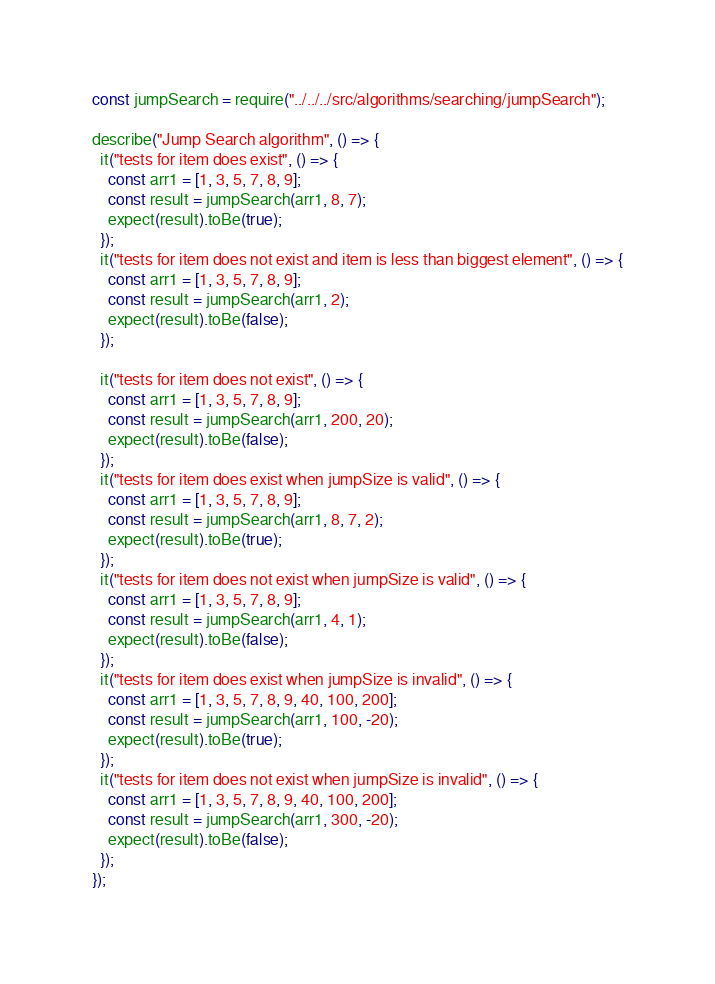<code> <loc_0><loc_0><loc_500><loc_500><_JavaScript_>const jumpSearch = require("../../../src/algorithms/searching/jumpSearch");

describe("Jump Search algorithm", () => {
  it("tests for item does exist", () => {
    const arr1 = [1, 3, 5, 7, 8, 9];
    const result = jumpSearch(arr1, 8, 7);
    expect(result).toBe(true);
  });
  it("tests for item does not exist and item is less than biggest element", () => {
    const arr1 = [1, 3, 5, 7, 8, 9];
    const result = jumpSearch(arr1, 2);
    expect(result).toBe(false);
  });

  it("tests for item does not exist", () => {
    const arr1 = [1, 3, 5, 7, 8, 9];
    const result = jumpSearch(arr1, 200, 20);
    expect(result).toBe(false);
  });
  it("tests for item does exist when jumpSize is valid", () => {
    const arr1 = [1, 3, 5, 7, 8, 9];
    const result = jumpSearch(arr1, 8, 7, 2);
    expect(result).toBe(true);
  });
  it("tests for item does not exist when jumpSize is valid", () => {
    const arr1 = [1, 3, 5, 7, 8, 9];
    const result = jumpSearch(arr1, 4, 1);
    expect(result).toBe(false);
  });
  it("tests for item does exist when jumpSize is invalid", () => {
    const arr1 = [1, 3, 5, 7, 8, 9, 40, 100, 200];
    const result = jumpSearch(arr1, 100, -20);
    expect(result).toBe(true);
  });
  it("tests for item does not exist when jumpSize is invalid", () => {
    const arr1 = [1, 3, 5, 7, 8, 9, 40, 100, 200];
    const result = jumpSearch(arr1, 300, -20);
    expect(result).toBe(false);
  });
});
</code> 